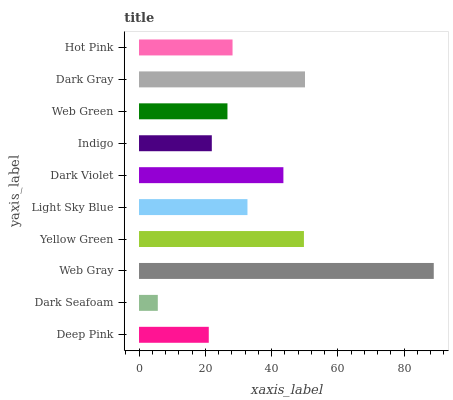Is Dark Seafoam the minimum?
Answer yes or no. Yes. Is Web Gray the maximum?
Answer yes or no. Yes. Is Web Gray the minimum?
Answer yes or no. No. Is Dark Seafoam the maximum?
Answer yes or no. No. Is Web Gray greater than Dark Seafoam?
Answer yes or no. Yes. Is Dark Seafoam less than Web Gray?
Answer yes or no. Yes. Is Dark Seafoam greater than Web Gray?
Answer yes or no. No. Is Web Gray less than Dark Seafoam?
Answer yes or no. No. Is Light Sky Blue the high median?
Answer yes or no. Yes. Is Hot Pink the low median?
Answer yes or no. Yes. Is Web Green the high median?
Answer yes or no. No. Is Deep Pink the low median?
Answer yes or no. No. 